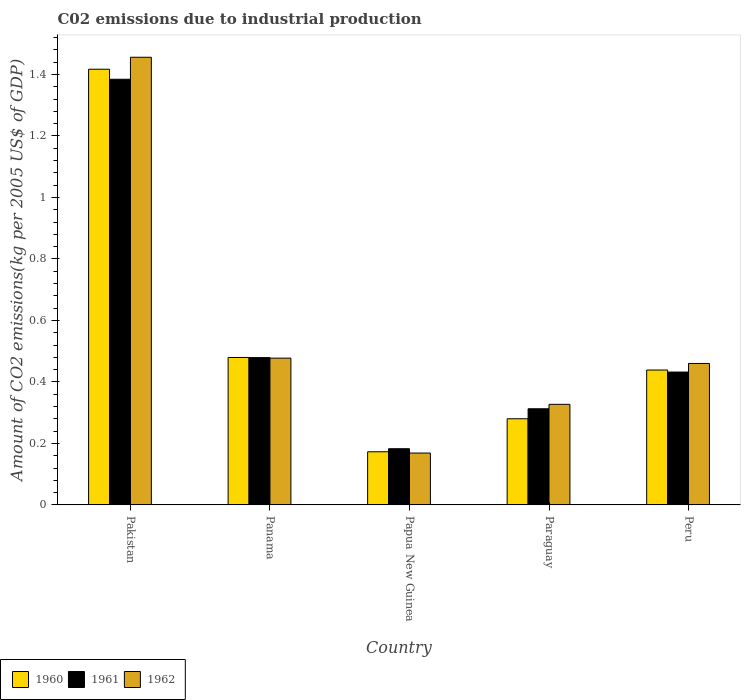How many different coloured bars are there?
Ensure brevity in your answer.  3. How many groups of bars are there?
Offer a very short reply. 5. Are the number of bars on each tick of the X-axis equal?
Ensure brevity in your answer.  Yes. How many bars are there on the 2nd tick from the right?
Offer a very short reply. 3. What is the label of the 4th group of bars from the left?
Provide a short and direct response. Paraguay. What is the amount of CO2 emitted due to industrial production in 1960 in Papua New Guinea?
Keep it short and to the point. 0.17. Across all countries, what is the maximum amount of CO2 emitted due to industrial production in 1961?
Keep it short and to the point. 1.38. Across all countries, what is the minimum amount of CO2 emitted due to industrial production in 1962?
Your answer should be compact. 0.17. In which country was the amount of CO2 emitted due to industrial production in 1962 minimum?
Your answer should be very brief. Papua New Guinea. What is the total amount of CO2 emitted due to industrial production in 1962 in the graph?
Make the answer very short. 2.89. What is the difference between the amount of CO2 emitted due to industrial production in 1962 in Papua New Guinea and that in Peru?
Provide a short and direct response. -0.29. What is the difference between the amount of CO2 emitted due to industrial production in 1961 in Papua New Guinea and the amount of CO2 emitted due to industrial production in 1962 in Panama?
Keep it short and to the point. -0.29. What is the average amount of CO2 emitted due to industrial production in 1962 per country?
Ensure brevity in your answer.  0.58. What is the difference between the amount of CO2 emitted due to industrial production of/in 1961 and amount of CO2 emitted due to industrial production of/in 1962 in Paraguay?
Offer a terse response. -0.01. What is the ratio of the amount of CO2 emitted due to industrial production in 1962 in Panama to that in Peru?
Ensure brevity in your answer.  1.04. Is the amount of CO2 emitted due to industrial production in 1960 in Panama less than that in Papua New Guinea?
Your answer should be very brief. No. What is the difference between the highest and the second highest amount of CO2 emitted due to industrial production in 1962?
Make the answer very short. -0.98. What is the difference between the highest and the lowest amount of CO2 emitted due to industrial production in 1960?
Your answer should be compact. 1.24. Is the sum of the amount of CO2 emitted due to industrial production in 1960 in Papua New Guinea and Paraguay greater than the maximum amount of CO2 emitted due to industrial production in 1962 across all countries?
Ensure brevity in your answer.  No. What does the 3rd bar from the right in Papua New Guinea represents?
Ensure brevity in your answer.  1960. How many bars are there?
Offer a terse response. 15. Are all the bars in the graph horizontal?
Make the answer very short. No. What is the difference between two consecutive major ticks on the Y-axis?
Provide a succinct answer. 0.2. Are the values on the major ticks of Y-axis written in scientific E-notation?
Give a very brief answer. No. Does the graph contain any zero values?
Your answer should be compact. No. Does the graph contain grids?
Your answer should be very brief. No. Where does the legend appear in the graph?
Offer a very short reply. Bottom left. What is the title of the graph?
Offer a terse response. C02 emissions due to industrial production. What is the label or title of the X-axis?
Keep it short and to the point. Country. What is the label or title of the Y-axis?
Keep it short and to the point. Amount of CO2 emissions(kg per 2005 US$ of GDP). What is the Amount of CO2 emissions(kg per 2005 US$ of GDP) of 1960 in Pakistan?
Keep it short and to the point. 1.42. What is the Amount of CO2 emissions(kg per 2005 US$ of GDP) of 1961 in Pakistan?
Offer a very short reply. 1.38. What is the Amount of CO2 emissions(kg per 2005 US$ of GDP) of 1962 in Pakistan?
Your answer should be very brief. 1.46. What is the Amount of CO2 emissions(kg per 2005 US$ of GDP) of 1960 in Panama?
Your answer should be very brief. 0.48. What is the Amount of CO2 emissions(kg per 2005 US$ of GDP) in 1961 in Panama?
Make the answer very short. 0.48. What is the Amount of CO2 emissions(kg per 2005 US$ of GDP) of 1962 in Panama?
Ensure brevity in your answer.  0.48. What is the Amount of CO2 emissions(kg per 2005 US$ of GDP) in 1960 in Papua New Guinea?
Offer a terse response. 0.17. What is the Amount of CO2 emissions(kg per 2005 US$ of GDP) of 1961 in Papua New Guinea?
Provide a short and direct response. 0.18. What is the Amount of CO2 emissions(kg per 2005 US$ of GDP) of 1962 in Papua New Guinea?
Keep it short and to the point. 0.17. What is the Amount of CO2 emissions(kg per 2005 US$ of GDP) in 1960 in Paraguay?
Your response must be concise. 0.28. What is the Amount of CO2 emissions(kg per 2005 US$ of GDP) in 1961 in Paraguay?
Provide a short and direct response. 0.31. What is the Amount of CO2 emissions(kg per 2005 US$ of GDP) of 1962 in Paraguay?
Keep it short and to the point. 0.33. What is the Amount of CO2 emissions(kg per 2005 US$ of GDP) in 1960 in Peru?
Provide a short and direct response. 0.44. What is the Amount of CO2 emissions(kg per 2005 US$ of GDP) of 1961 in Peru?
Give a very brief answer. 0.43. What is the Amount of CO2 emissions(kg per 2005 US$ of GDP) in 1962 in Peru?
Your answer should be compact. 0.46. Across all countries, what is the maximum Amount of CO2 emissions(kg per 2005 US$ of GDP) of 1960?
Your answer should be compact. 1.42. Across all countries, what is the maximum Amount of CO2 emissions(kg per 2005 US$ of GDP) in 1961?
Provide a succinct answer. 1.38. Across all countries, what is the maximum Amount of CO2 emissions(kg per 2005 US$ of GDP) of 1962?
Keep it short and to the point. 1.46. Across all countries, what is the minimum Amount of CO2 emissions(kg per 2005 US$ of GDP) of 1960?
Offer a very short reply. 0.17. Across all countries, what is the minimum Amount of CO2 emissions(kg per 2005 US$ of GDP) in 1961?
Make the answer very short. 0.18. Across all countries, what is the minimum Amount of CO2 emissions(kg per 2005 US$ of GDP) of 1962?
Offer a terse response. 0.17. What is the total Amount of CO2 emissions(kg per 2005 US$ of GDP) of 1960 in the graph?
Give a very brief answer. 2.79. What is the total Amount of CO2 emissions(kg per 2005 US$ of GDP) in 1961 in the graph?
Offer a terse response. 2.79. What is the total Amount of CO2 emissions(kg per 2005 US$ of GDP) of 1962 in the graph?
Offer a very short reply. 2.89. What is the difference between the Amount of CO2 emissions(kg per 2005 US$ of GDP) of 1960 in Pakistan and that in Panama?
Ensure brevity in your answer.  0.94. What is the difference between the Amount of CO2 emissions(kg per 2005 US$ of GDP) in 1961 in Pakistan and that in Panama?
Keep it short and to the point. 0.91. What is the difference between the Amount of CO2 emissions(kg per 2005 US$ of GDP) of 1962 in Pakistan and that in Panama?
Provide a short and direct response. 0.98. What is the difference between the Amount of CO2 emissions(kg per 2005 US$ of GDP) in 1960 in Pakistan and that in Papua New Guinea?
Offer a very short reply. 1.24. What is the difference between the Amount of CO2 emissions(kg per 2005 US$ of GDP) in 1961 in Pakistan and that in Papua New Guinea?
Offer a very short reply. 1.2. What is the difference between the Amount of CO2 emissions(kg per 2005 US$ of GDP) of 1962 in Pakistan and that in Papua New Guinea?
Your answer should be compact. 1.29. What is the difference between the Amount of CO2 emissions(kg per 2005 US$ of GDP) of 1960 in Pakistan and that in Paraguay?
Offer a terse response. 1.14. What is the difference between the Amount of CO2 emissions(kg per 2005 US$ of GDP) of 1961 in Pakistan and that in Paraguay?
Give a very brief answer. 1.07. What is the difference between the Amount of CO2 emissions(kg per 2005 US$ of GDP) in 1962 in Pakistan and that in Paraguay?
Provide a succinct answer. 1.13. What is the difference between the Amount of CO2 emissions(kg per 2005 US$ of GDP) in 1960 in Pakistan and that in Peru?
Make the answer very short. 0.98. What is the difference between the Amount of CO2 emissions(kg per 2005 US$ of GDP) in 1961 in Pakistan and that in Peru?
Ensure brevity in your answer.  0.95. What is the difference between the Amount of CO2 emissions(kg per 2005 US$ of GDP) of 1962 in Pakistan and that in Peru?
Ensure brevity in your answer.  1. What is the difference between the Amount of CO2 emissions(kg per 2005 US$ of GDP) in 1960 in Panama and that in Papua New Guinea?
Offer a very short reply. 0.31. What is the difference between the Amount of CO2 emissions(kg per 2005 US$ of GDP) of 1961 in Panama and that in Papua New Guinea?
Provide a short and direct response. 0.3. What is the difference between the Amount of CO2 emissions(kg per 2005 US$ of GDP) of 1962 in Panama and that in Papua New Guinea?
Your answer should be compact. 0.31. What is the difference between the Amount of CO2 emissions(kg per 2005 US$ of GDP) of 1960 in Panama and that in Paraguay?
Make the answer very short. 0.2. What is the difference between the Amount of CO2 emissions(kg per 2005 US$ of GDP) of 1961 in Panama and that in Paraguay?
Offer a very short reply. 0.17. What is the difference between the Amount of CO2 emissions(kg per 2005 US$ of GDP) of 1962 in Panama and that in Paraguay?
Provide a short and direct response. 0.15. What is the difference between the Amount of CO2 emissions(kg per 2005 US$ of GDP) of 1960 in Panama and that in Peru?
Ensure brevity in your answer.  0.04. What is the difference between the Amount of CO2 emissions(kg per 2005 US$ of GDP) of 1961 in Panama and that in Peru?
Give a very brief answer. 0.05. What is the difference between the Amount of CO2 emissions(kg per 2005 US$ of GDP) of 1962 in Panama and that in Peru?
Offer a terse response. 0.02. What is the difference between the Amount of CO2 emissions(kg per 2005 US$ of GDP) in 1960 in Papua New Guinea and that in Paraguay?
Offer a terse response. -0.11. What is the difference between the Amount of CO2 emissions(kg per 2005 US$ of GDP) in 1961 in Papua New Guinea and that in Paraguay?
Provide a short and direct response. -0.13. What is the difference between the Amount of CO2 emissions(kg per 2005 US$ of GDP) of 1962 in Papua New Guinea and that in Paraguay?
Your answer should be compact. -0.16. What is the difference between the Amount of CO2 emissions(kg per 2005 US$ of GDP) of 1960 in Papua New Guinea and that in Peru?
Offer a terse response. -0.27. What is the difference between the Amount of CO2 emissions(kg per 2005 US$ of GDP) of 1961 in Papua New Guinea and that in Peru?
Your response must be concise. -0.25. What is the difference between the Amount of CO2 emissions(kg per 2005 US$ of GDP) of 1962 in Papua New Guinea and that in Peru?
Ensure brevity in your answer.  -0.29. What is the difference between the Amount of CO2 emissions(kg per 2005 US$ of GDP) in 1960 in Paraguay and that in Peru?
Provide a succinct answer. -0.16. What is the difference between the Amount of CO2 emissions(kg per 2005 US$ of GDP) of 1961 in Paraguay and that in Peru?
Provide a short and direct response. -0.12. What is the difference between the Amount of CO2 emissions(kg per 2005 US$ of GDP) in 1962 in Paraguay and that in Peru?
Give a very brief answer. -0.13. What is the difference between the Amount of CO2 emissions(kg per 2005 US$ of GDP) in 1960 in Pakistan and the Amount of CO2 emissions(kg per 2005 US$ of GDP) in 1961 in Panama?
Ensure brevity in your answer.  0.94. What is the difference between the Amount of CO2 emissions(kg per 2005 US$ of GDP) in 1960 in Pakistan and the Amount of CO2 emissions(kg per 2005 US$ of GDP) in 1962 in Panama?
Give a very brief answer. 0.94. What is the difference between the Amount of CO2 emissions(kg per 2005 US$ of GDP) in 1961 in Pakistan and the Amount of CO2 emissions(kg per 2005 US$ of GDP) in 1962 in Panama?
Make the answer very short. 0.91. What is the difference between the Amount of CO2 emissions(kg per 2005 US$ of GDP) of 1960 in Pakistan and the Amount of CO2 emissions(kg per 2005 US$ of GDP) of 1961 in Papua New Guinea?
Your answer should be very brief. 1.23. What is the difference between the Amount of CO2 emissions(kg per 2005 US$ of GDP) of 1960 in Pakistan and the Amount of CO2 emissions(kg per 2005 US$ of GDP) of 1962 in Papua New Guinea?
Your response must be concise. 1.25. What is the difference between the Amount of CO2 emissions(kg per 2005 US$ of GDP) of 1961 in Pakistan and the Amount of CO2 emissions(kg per 2005 US$ of GDP) of 1962 in Papua New Guinea?
Give a very brief answer. 1.22. What is the difference between the Amount of CO2 emissions(kg per 2005 US$ of GDP) in 1960 in Pakistan and the Amount of CO2 emissions(kg per 2005 US$ of GDP) in 1961 in Paraguay?
Give a very brief answer. 1.1. What is the difference between the Amount of CO2 emissions(kg per 2005 US$ of GDP) in 1960 in Pakistan and the Amount of CO2 emissions(kg per 2005 US$ of GDP) in 1962 in Paraguay?
Give a very brief answer. 1.09. What is the difference between the Amount of CO2 emissions(kg per 2005 US$ of GDP) of 1961 in Pakistan and the Amount of CO2 emissions(kg per 2005 US$ of GDP) of 1962 in Paraguay?
Provide a succinct answer. 1.06. What is the difference between the Amount of CO2 emissions(kg per 2005 US$ of GDP) in 1960 in Pakistan and the Amount of CO2 emissions(kg per 2005 US$ of GDP) in 1961 in Peru?
Ensure brevity in your answer.  0.98. What is the difference between the Amount of CO2 emissions(kg per 2005 US$ of GDP) of 1960 in Pakistan and the Amount of CO2 emissions(kg per 2005 US$ of GDP) of 1962 in Peru?
Your answer should be very brief. 0.96. What is the difference between the Amount of CO2 emissions(kg per 2005 US$ of GDP) in 1961 in Pakistan and the Amount of CO2 emissions(kg per 2005 US$ of GDP) in 1962 in Peru?
Offer a terse response. 0.92. What is the difference between the Amount of CO2 emissions(kg per 2005 US$ of GDP) in 1960 in Panama and the Amount of CO2 emissions(kg per 2005 US$ of GDP) in 1961 in Papua New Guinea?
Give a very brief answer. 0.3. What is the difference between the Amount of CO2 emissions(kg per 2005 US$ of GDP) of 1960 in Panama and the Amount of CO2 emissions(kg per 2005 US$ of GDP) of 1962 in Papua New Guinea?
Offer a very short reply. 0.31. What is the difference between the Amount of CO2 emissions(kg per 2005 US$ of GDP) in 1961 in Panama and the Amount of CO2 emissions(kg per 2005 US$ of GDP) in 1962 in Papua New Guinea?
Provide a succinct answer. 0.31. What is the difference between the Amount of CO2 emissions(kg per 2005 US$ of GDP) of 1960 in Panama and the Amount of CO2 emissions(kg per 2005 US$ of GDP) of 1961 in Paraguay?
Your answer should be compact. 0.17. What is the difference between the Amount of CO2 emissions(kg per 2005 US$ of GDP) in 1960 in Panama and the Amount of CO2 emissions(kg per 2005 US$ of GDP) in 1962 in Paraguay?
Provide a short and direct response. 0.15. What is the difference between the Amount of CO2 emissions(kg per 2005 US$ of GDP) in 1961 in Panama and the Amount of CO2 emissions(kg per 2005 US$ of GDP) in 1962 in Paraguay?
Provide a short and direct response. 0.15. What is the difference between the Amount of CO2 emissions(kg per 2005 US$ of GDP) in 1960 in Panama and the Amount of CO2 emissions(kg per 2005 US$ of GDP) in 1961 in Peru?
Your answer should be very brief. 0.05. What is the difference between the Amount of CO2 emissions(kg per 2005 US$ of GDP) in 1960 in Panama and the Amount of CO2 emissions(kg per 2005 US$ of GDP) in 1962 in Peru?
Give a very brief answer. 0.02. What is the difference between the Amount of CO2 emissions(kg per 2005 US$ of GDP) in 1961 in Panama and the Amount of CO2 emissions(kg per 2005 US$ of GDP) in 1962 in Peru?
Keep it short and to the point. 0.02. What is the difference between the Amount of CO2 emissions(kg per 2005 US$ of GDP) in 1960 in Papua New Guinea and the Amount of CO2 emissions(kg per 2005 US$ of GDP) in 1961 in Paraguay?
Your answer should be compact. -0.14. What is the difference between the Amount of CO2 emissions(kg per 2005 US$ of GDP) in 1960 in Papua New Guinea and the Amount of CO2 emissions(kg per 2005 US$ of GDP) in 1962 in Paraguay?
Keep it short and to the point. -0.15. What is the difference between the Amount of CO2 emissions(kg per 2005 US$ of GDP) of 1961 in Papua New Guinea and the Amount of CO2 emissions(kg per 2005 US$ of GDP) of 1962 in Paraguay?
Your answer should be very brief. -0.14. What is the difference between the Amount of CO2 emissions(kg per 2005 US$ of GDP) of 1960 in Papua New Guinea and the Amount of CO2 emissions(kg per 2005 US$ of GDP) of 1961 in Peru?
Provide a succinct answer. -0.26. What is the difference between the Amount of CO2 emissions(kg per 2005 US$ of GDP) of 1960 in Papua New Guinea and the Amount of CO2 emissions(kg per 2005 US$ of GDP) of 1962 in Peru?
Offer a very short reply. -0.29. What is the difference between the Amount of CO2 emissions(kg per 2005 US$ of GDP) in 1961 in Papua New Guinea and the Amount of CO2 emissions(kg per 2005 US$ of GDP) in 1962 in Peru?
Your answer should be very brief. -0.28. What is the difference between the Amount of CO2 emissions(kg per 2005 US$ of GDP) of 1960 in Paraguay and the Amount of CO2 emissions(kg per 2005 US$ of GDP) of 1961 in Peru?
Make the answer very short. -0.15. What is the difference between the Amount of CO2 emissions(kg per 2005 US$ of GDP) of 1960 in Paraguay and the Amount of CO2 emissions(kg per 2005 US$ of GDP) of 1962 in Peru?
Your answer should be very brief. -0.18. What is the difference between the Amount of CO2 emissions(kg per 2005 US$ of GDP) of 1961 in Paraguay and the Amount of CO2 emissions(kg per 2005 US$ of GDP) of 1962 in Peru?
Your answer should be compact. -0.15. What is the average Amount of CO2 emissions(kg per 2005 US$ of GDP) in 1960 per country?
Give a very brief answer. 0.56. What is the average Amount of CO2 emissions(kg per 2005 US$ of GDP) of 1961 per country?
Your answer should be compact. 0.56. What is the average Amount of CO2 emissions(kg per 2005 US$ of GDP) in 1962 per country?
Give a very brief answer. 0.58. What is the difference between the Amount of CO2 emissions(kg per 2005 US$ of GDP) in 1960 and Amount of CO2 emissions(kg per 2005 US$ of GDP) in 1961 in Pakistan?
Offer a very short reply. 0.03. What is the difference between the Amount of CO2 emissions(kg per 2005 US$ of GDP) in 1960 and Amount of CO2 emissions(kg per 2005 US$ of GDP) in 1962 in Pakistan?
Offer a terse response. -0.04. What is the difference between the Amount of CO2 emissions(kg per 2005 US$ of GDP) in 1961 and Amount of CO2 emissions(kg per 2005 US$ of GDP) in 1962 in Pakistan?
Ensure brevity in your answer.  -0.07. What is the difference between the Amount of CO2 emissions(kg per 2005 US$ of GDP) in 1960 and Amount of CO2 emissions(kg per 2005 US$ of GDP) in 1962 in Panama?
Provide a short and direct response. 0. What is the difference between the Amount of CO2 emissions(kg per 2005 US$ of GDP) in 1961 and Amount of CO2 emissions(kg per 2005 US$ of GDP) in 1962 in Panama?
Give a very brief answer. 0. What is the difference between the Amount of CO2 emissions(kg per 2005 US$ of GDP) in 1960 and Amount of CO2 emissions(kg per 2005 US$ of GDP) in 1961 in Papua New Guinea?
Keep it short and to the point. -0.01. What is the difference between the Amount of CO2 emissions(kg per 2005 US$ of GDP) in 1960 and Amount of CO2 emissions(kg per 2005 US$ of GDP) in 1962 in Papua New Guinea?
Provide a short and direct response. 0. What is the difference between the Amount of CO2 emissions(kg per 2005 US$ of GDP) in 1961 and Amount of CO2 emissions(kg per 2005 US$ of GDP) in 1962 in Papua New Guinea?
Make the answer very short. 0.01. What is the difference between the Amount of CO2 emissions(kg per 2005 US$ of GDP) in 1960 and Amount of CO2 emissions(kg per 2005 US$ of GDP) in 1961 in Paraguay?
Offer a very short reply. -0.03. What is the difference between the Amount of CO2 emissions(kg per 2005 US$ of GDP) in 1960 and Amount of CO2 emissions(kg per 2005 US$ of GDP) in 1962 in Paraguay?
Your response must be concise. -0.05. What is the difference between the Amount of CO2 emissions(kg per 2005 US$ of GDP) in 1961 and Amount of CO2 emissions(kg per 2005 US$ of GDP) in 1962 in Paraguay?
Offer a very short reply. -0.01. What is the difference between the Amount of CO2 emissions(kg per 2005 US$ of GDP) in 1960 and Amount of CO2 emissions(kg per 2005 US$ of GDP) in 1961 in Peru?
Provide a short and direct response. 0.01. What is the difference between the Amount of CO2 emissions(kg per 2005 US$ of GDP) of 1960 and Amount of CO2 emissions(kg per 2005 US$ of GDP) of 1962 in Peru?
Offer a very short reply. -0.02. What is the difference between the Amount of CO2 emissions(kg per 2005 US$ of GDP) in 1961 and Amount of CO2 emissions(kg per 2005 US$ of GDP) in 1962 in Peru?
Your answer should be compact. -0.03. What is the ratio of the Amount of CO2 emissions(kg per 2005 US$ of GDP) of 1960 in Pakistan to that in Panama?
Provide a short and direct response. 2.95. What is the ratio of the Amount of CO2 emissions(kg per 2005 US$ of GDP) in 1961 in Pakistan to that in Panama?
Provide a short and direct response. 2.89. What is the ratio of the Amount of CO2 emissions(kg per 2005 US$ of GDP) of 1962 in Pakistan to that in Panama?
Offer a terse response. 3.05. What is the ratio of the Amount of CO2 emissions(kg per 2005 US$ of GDP) in 1960 in Pakistan to that in Papua New Guinea?
Give a very brief answer. 8.2. What is the ratio of the Amount of CO2 emissions(kg per 2005 US$ of GDP) in 1961 in Pakistan to that in Papua New Guinea?
Offer a very short reply. 7.57. What is the ratio of the Amount of CO2 emissions(kg per 2005 US$ of GDP) in 1962 in Pakistan to that in Papua New Guinea?
Your response must be concise. 8.63. What is the ratio of the Amount of CO2 emissions(kg per 2005 US$ of GDP) of 1960 in Pakistan to that in Paraguay?
Your answer should be compact. 5.06. What is the ratio of the Amount of CO2 emissions(kg per 2005 US$ of GDP) of 1961 in Pakistan to that in Paraguay?
Give a very brief answer. 4.43. What is the ratio of the Amount of CO2 emissions(kg per 2005 US$ of GDP) in 1962 in Pakistan to that in Paraguay?
Provide a short and direct response. 4.45. What is the ratio of the Amount of CO2 emissions(kg per 2005 US$ of GDP) of 1960 in Pakistan to that in Peru?
Give a very brief answer. 3.23. What is the ratio of the Amount of CO2 emissions(kg per 2005 US$ of GDP) in 1961 in Pakistan to that in Peru?
Ensure brevity in your answer.  3.2. What is the ratio of the Amount of CO2 emissions(kg per 2005 US$ of GDP) in 1962 in Pakistan to that in Peru?
Ensure brevity in your answer.  3.16. What is the ratio of the Amount of CO2 emissions(kg per 2005 US$ of GDP) of 1960 in Panama to that in Papua New Guinea?
Make the answer very short. 2.77. What is the ratio of the Amount of CO2 emissions(kg per 2005 US$ of GDP) in 1961 in Panama to that in Papua New Guinea?
Ensure brevity in your answer.  2.62. What is the ratio of the Amount of CO2 emissions(kg per 2005 US$ of GDP) of 1962 in Panama to that in Papua New Guinea?
Your answer should be very brief. 2.83. What is the ratio of the Amount of CO2 emissions(kg per 2005 US$ of GDP) in 1960 in Panama to that in Paraguay?
Provide a succinct answer. 1.71. What is the ratio of the Amount of CO2 emissions(kg per 2005 US$ of GDP) in 1961 in Panama to that in Paraguay?
Provide a short and direct response. 1.53. What is the ratio of the Amount of CO2 emissions(kg per 2005 US$ of GDP) in 1962 in Panama to that in Paraguay?
Provide a succinct answer. 1.46. What is the ratio of the Amount of CO2 emissions(kg per 2005 US$ of GDP) of 1960 in Panama to that in Peru?
Provide a succinct answer. 1.09. What is the ratio of the Amount of CO2 emissions(kg per 2005 US$ of GDP) in 1961 in Panama to that in Peru?
Your response must be concise. 1.11. What is the ratio of the Amount of CO2 emissions(kg per 2005 US$ of GDP) in 1962 in Panama to that in Peru?
Provide a succinct answer. 1.04. What is the ratio of the Amount of CO2 emissions(kg per 2005 US$ of GDP) in 1960 in Papua New Guinea to that in Paraguay?
Your answer should be compact. 0.62. What is the ratio of the Amount of CO2 emissions(kg per 2005 US$ of GDP) in 1961 in Papua New Guinea to that in Paraguay?
Offer a very short reply. 0.58. What is the ratio of the Amount of CO2 emissions(kg per 2005 US$ of GDP) in 1962 in Papua New Guinea to that in Paraguay?
Give a very brief answer. 0.52. What is the ratio of the Amount of CO2 emissions(kg per 2005 US$ of GDP) of 1960 in Papua New Guinea to that in Peru?
Offer a very short reply. 0.39. What is the ratio of the Amount of CO2 emissions(kg per 2005 US$ of GDP) of 1961 in Papua New Guinea to that in Peru?
Offer a terse response. 0.42. What is the ratio of the Amount of CO2 emissions(kg per 2005 US$ of GDP) of 1962 in Papua New Guinea to that in Peru?
Your answer should be compact. 0.37. What is the ratio of the Amount of CO2 emissions(kg per 2005 US$ of GDP) in 1960 in Paraguay to that in Peru?
Provide a succinct answer. 0.64. What is the ratio of the Amount of CO2 emissions(kg per 2005 US$ of GDP) in 1961 in Paraguay to that in Peru?
Your answer should be compact. 0.72. What is the ratio of the Amount of CO2 emissions(kg per 2005 US$ of GDP) in 1962 in Paraguay to that in Peru?
Provide a succinct answer. 0.71. What is the difference between the highest and the second highest Amount of CO2 emissions(kg per 2005 US$ of GDP) of 1960?
Keep it short and to the point. 0.94. What is the difference between the highest and the second highest Amount of CO2 emissions(kg per 2005 US$ of GDP) in 1961?
Offer a very short reply. 0.91. What is the difference between the highest and the second highest Amount of CO2 emissions(kg per 2005 US$ of GDP) in 1962?
Keep it short and to the point. 0.98. What is the difference between the highest and the lowest Amount of CO2 emissions(kg per 2005 US$ of GDP) in 1960?
Your response must be concise. 1.24. What is the difference between the highest and the lowest Amount of CO2 emissions(kg per 2005 US$ of GDP) of 1961?
Give a very brief answer. 1.2. What is the difference between the highest and the lowest Amount of CO2 emissions(kg per 2005 US$ of GDP) in 1962?
Provide a succinct answer. 1.29. 